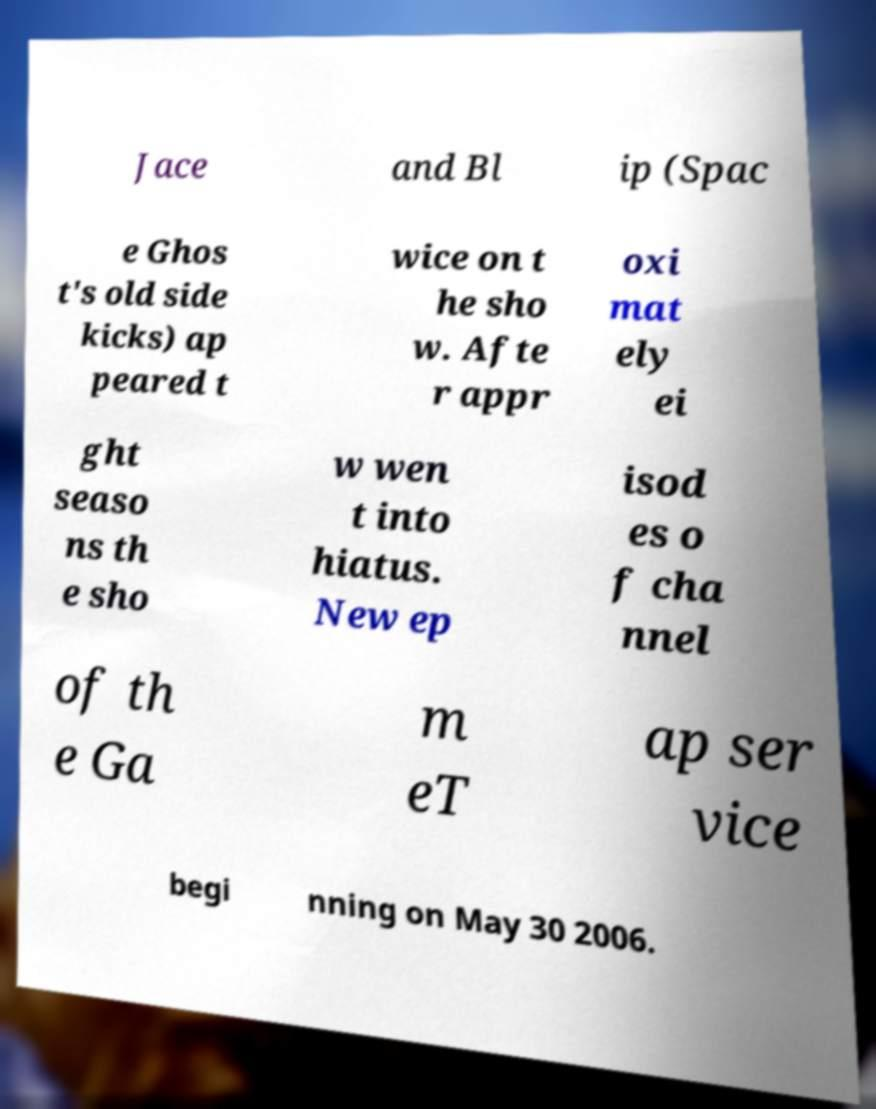Can you read and provide the text displayed in the image?This photo seems to have some interesting text. Can you extract and type it out for me? Jace and Bl ip (Spac e Ghos t's old side kicks) ap peared t wice on t he sho w. Afte r appr oxi mat ely ei ght seaso ns th e sho w wen t into hiatus. New ep isod es o f cha nnel of th e Ga m eT ap ser vice begi nning on May 30 2006. 